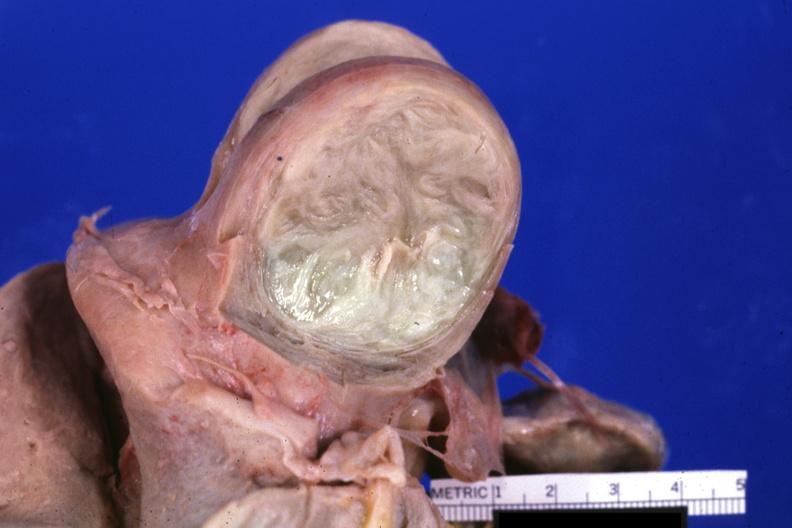what is fixed tissue cut?
Answer the question using a single word or phrase. Surface of typical myoma 